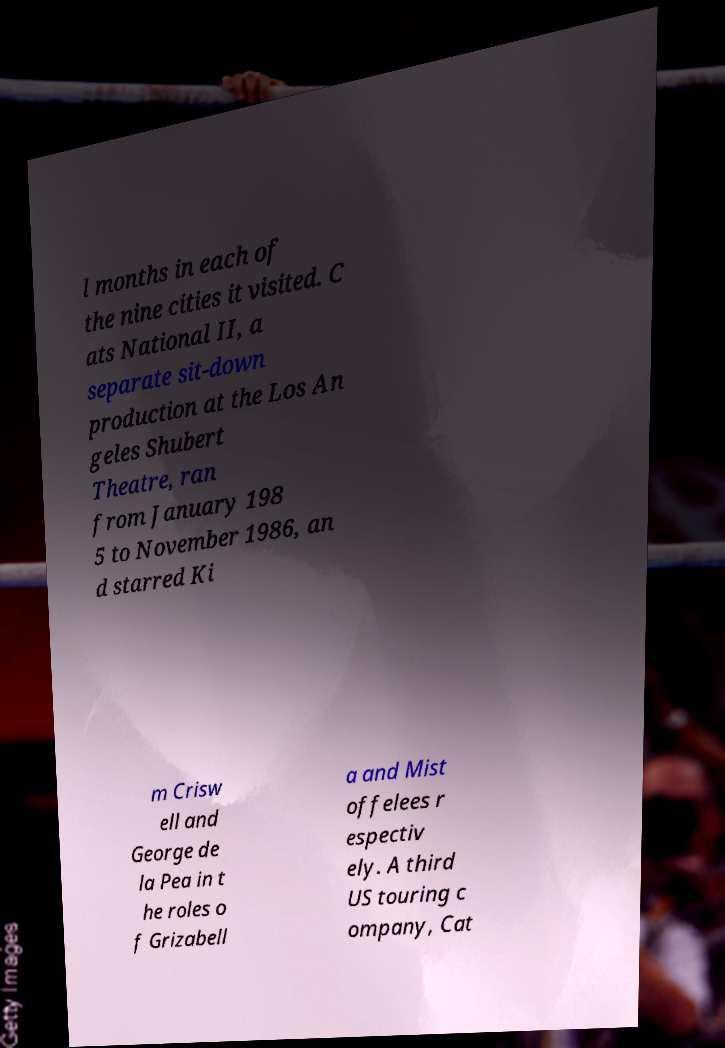Please read and relay the text visible in this image. What does it say? l months in each of the nine cities it visited. C ats National II, a separate sit-down production at the Los An geles Shubert Theatre, ran from January 198 5 to November 1986, an d starred Ki m Crisw ell and George de la Pea in t he roles o f Grizabell a and Mist offelees r espectiv ely. A third US touring c ompany, Cat 